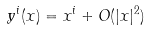<formula> <loc_0><loc_0><loc_500><loc_500>y ^ { i } ( x ) = x ^ { i } + O ( | x | ^ { 2 } )</formula> 